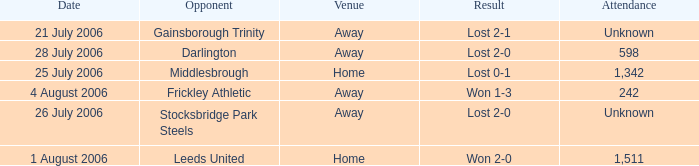What is the attendance rate for the Middlesbrough opponent? 1342.0. 